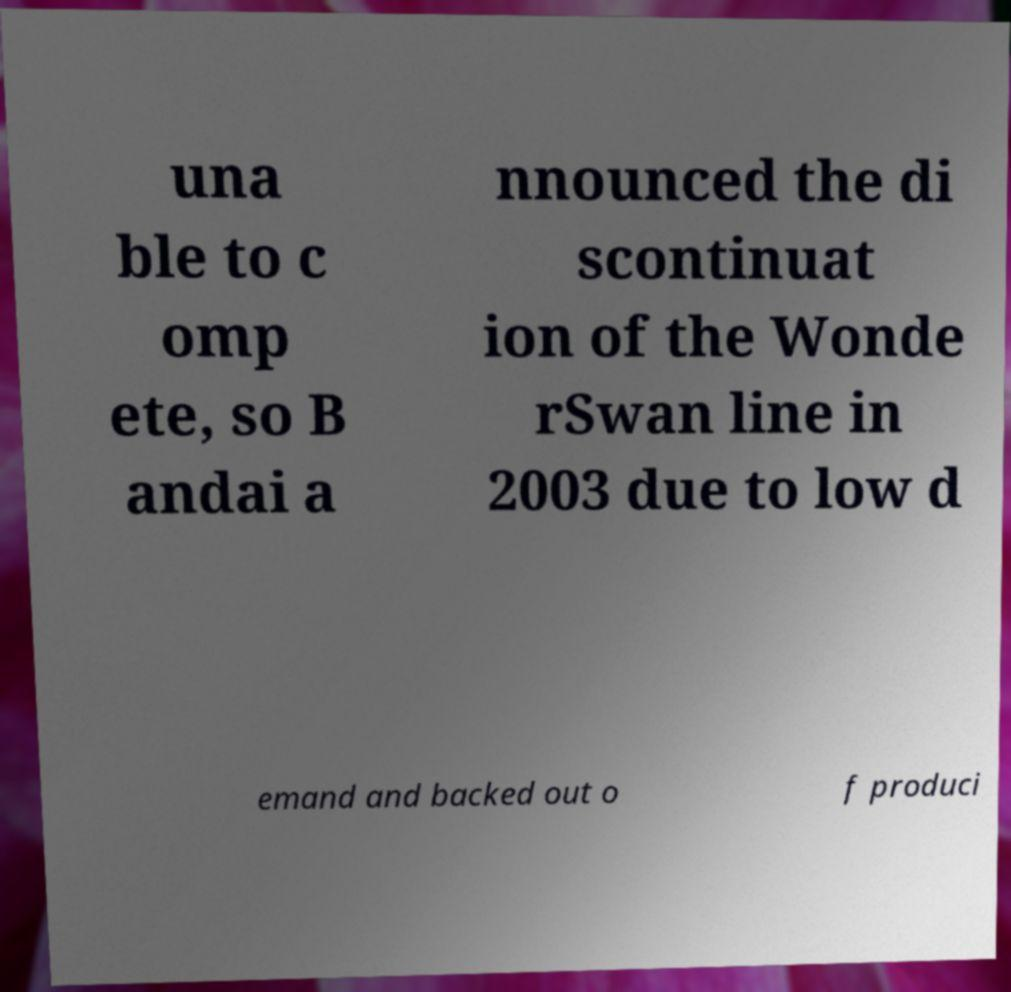There's text embedded in this image that I need extracted. Can you transcribe it verbatim? una ble to c omp ete, so B andai a nnounced the di scontinuat ion of the Wonde rSwan line in 2003 due to low d emand and backed out o f produci 